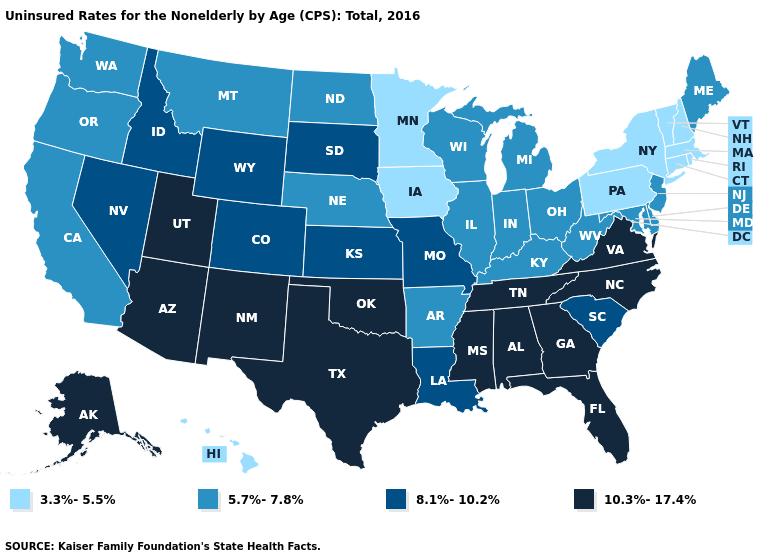Which states have the lowest value in the USA?
Give a very brief answer. Connecticut, Hawaii, Iowa, Massachusetts, Minnesota, New Hampshire, New York, Pennsylvania, Rhode Island, Vermont. What is the lowest value in the South?
Quick response, please. 5.7%-7.8%. Does Maine have the lowest value in the USA?
Short answer required. No. Among the states that border New Mexico , does Colorado have the highest value?
Concise answer only. No. What is the lowest value in the South?
Write a very short answer. 5.7%-7.8%. Among the states that border Texas , does Louisiana have the lowest value?
Answer briefly. No. What is the lowest value in the Northeast?
Keep it brief. 3.3%-5.5%. What is the highest value in the USA?
Write a very short answer. 10.3%-17.4%. What is the value of Washington?
Be succinct. 5.7%-7.8%. Does Vermont have a lower value than Hawaii?
Concise answer only. No. What is the highest value in the Northeast ?
Answer briefly. 5.7%-7.8%. What is the lowest value in states that border Ohio?
Short answer required. 3.3%-5.5%. What is the value of Massachusetts?
Concise answer only. 3.3%-5.5%. How many symbols are there in the legend?
Give a very brief answer. 4. Name the states that have a value in the range 8.1%-10.2%?
Keep it brief. Colorado, Idaho, Kansas, Louisiana, Missouri, Nevada, South Carolina, South Dakota, Wyoming. 